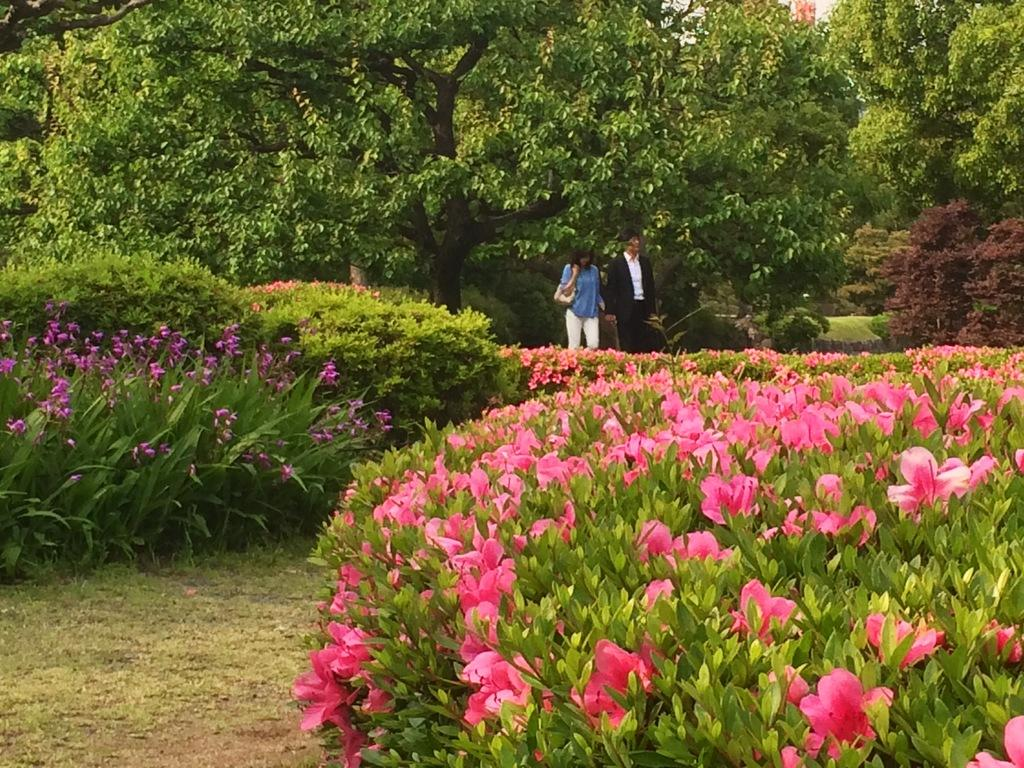How many people are in the image? There are people in the image, but the exact number is not specified. What is one person doing in the image? One person is carrying a bag. What type of surface is visible in the image? There is ground visible in the image, and grass is present on the ground. What type of vegetation can be seen in the image? Plants, flowers, and trees are visible in the image. What type of engine can be seen powering the ant in the image? There is no ant or engine present in the image. How many needles are being used by the person carrying the bag in the image? There is no mention of needles in the image, and the person carrying the bag is not using any. 